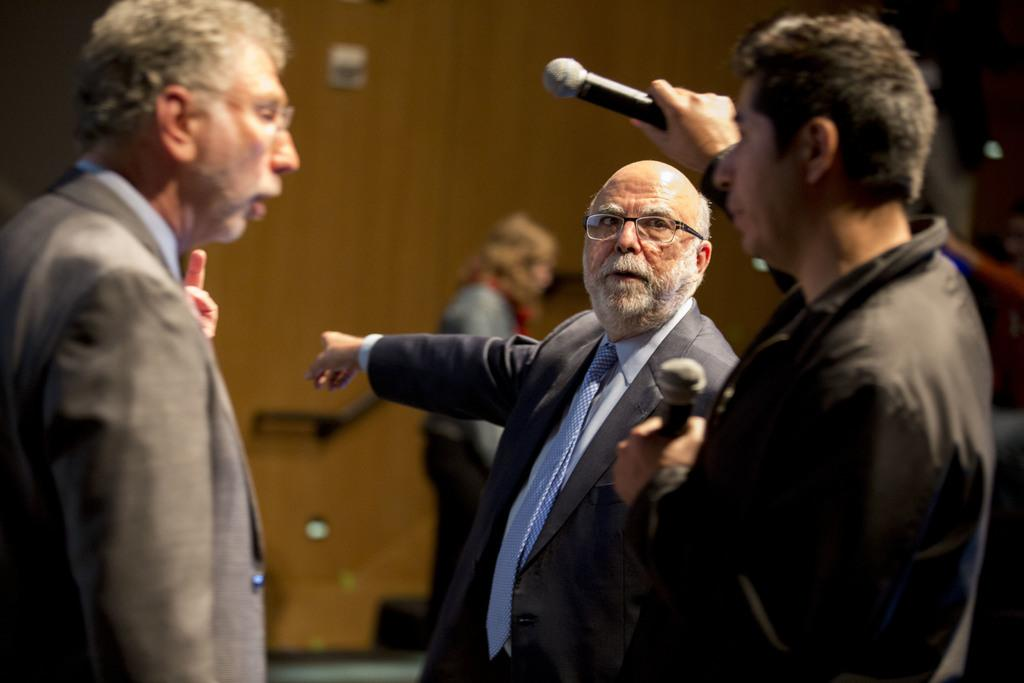How many people are in the image? There are three men standing in the image. Can you describe the clothing of one of the men? One of the men is wearing a black jacket. What is the man in the black jacket holding in both hands? The man in the black jacket is holding a mic in both hands. What position do the things take in the image? There are no "things" mentioned in the image; the image features three men, one of whom is wearing a black jacket and holding a mic. Can you describe the swimming attire of the men in the image? There is no swimming attire present in the image; the men are dressed in regular clothing. 